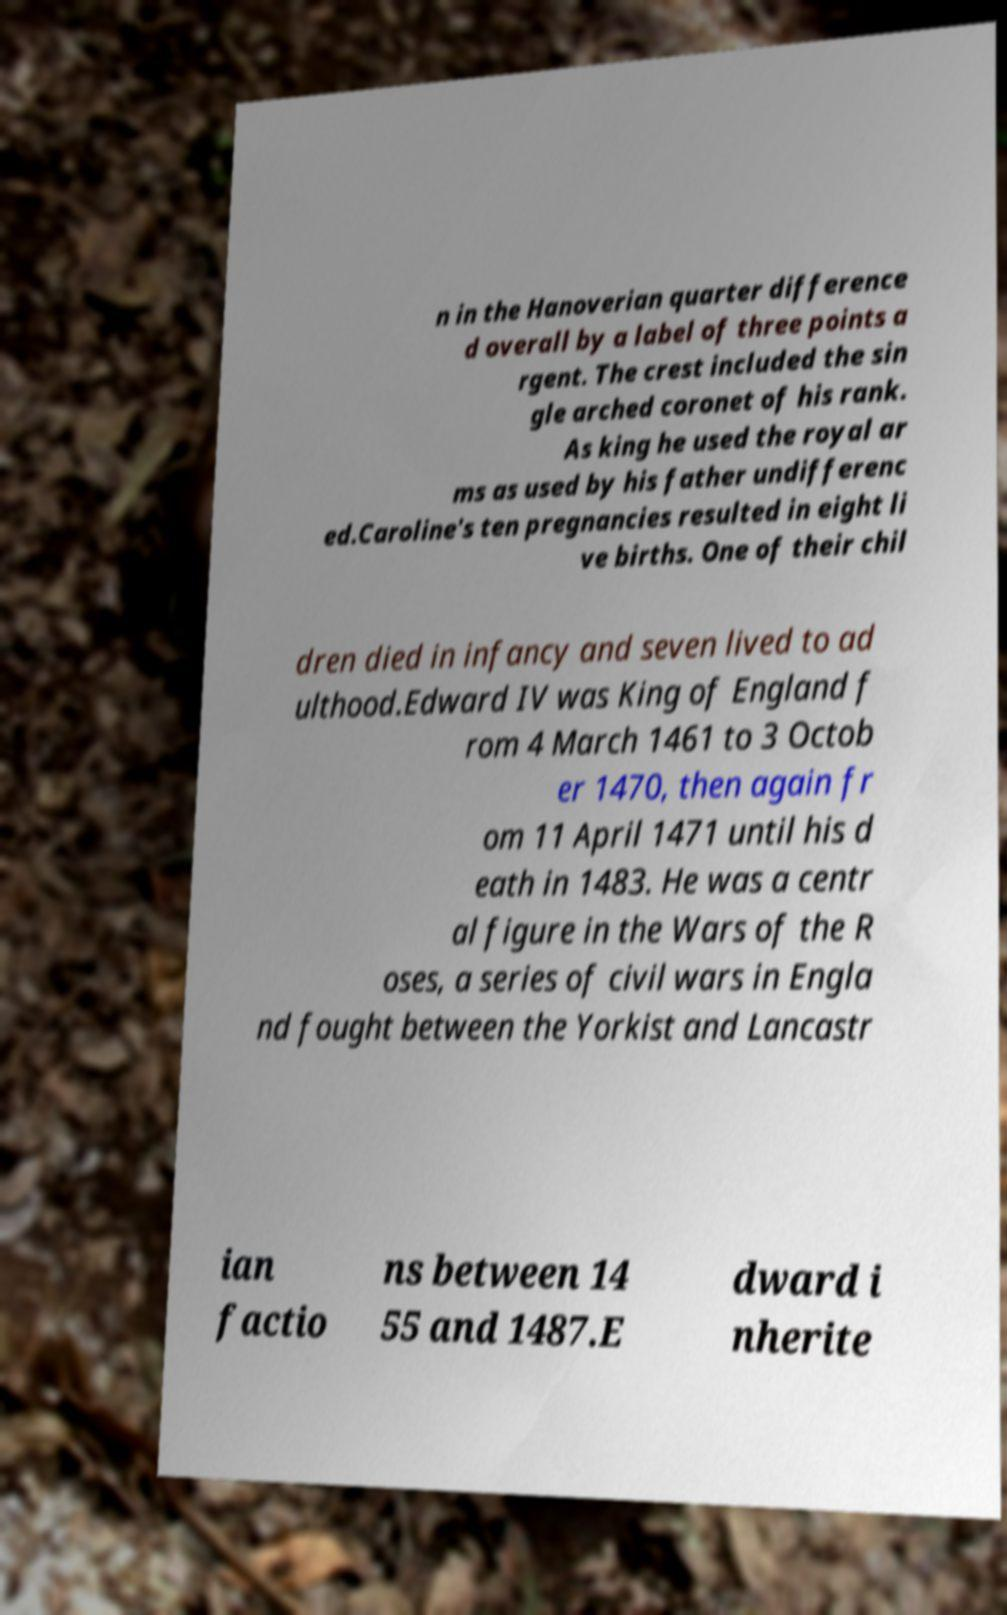For documentation purposes, I need the text within this image transcribed. Could you provide that? n in the Hanoverian quarter difference d overall by a label of three points a rgent. The crest included the sin gle arched coronet of his rank. As king he used the royal ar ms as used by his father undifferenc ed.Caroline's ten pregnancies resulted in eight li ve births. One of their chil dren died in infancy and seven lived to ad ulthood.Edward IV was King of England f rom 4 March 1461 to 3 Octob er 1470, then again fr om 11 April 1471 until his d eath in 1483. He was a centr al figure in the Wars of the R oses, a series of civil wars in Engla nd fought between the Yorkist and Lancastr ian factio ns between 14 55 and 1487.E dward i nherite 